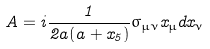<formula> <loc_0><loc_0><loc_500><loc_500>A = i \frac { 1 } { 2 a ( a + x _ { 5 } ) } \sigma _ { \mu \nu } x _ { \mu } d x _ { \nu }</formula> 